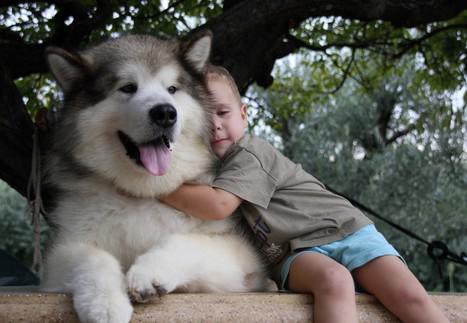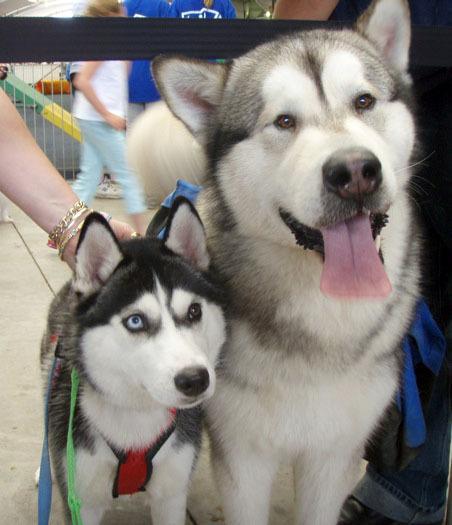The first image is the image on the left, the second image is the image on the right. Considering the images on both sides, is "At least one dog has its mouth open." valid? Answer yes or no. Yes. The first image is the image on the left, the second image is the image on the right. For the images displayed, is the sentence "There are less than 5 dogs." factually correct? Answer yes or no. Yes. 